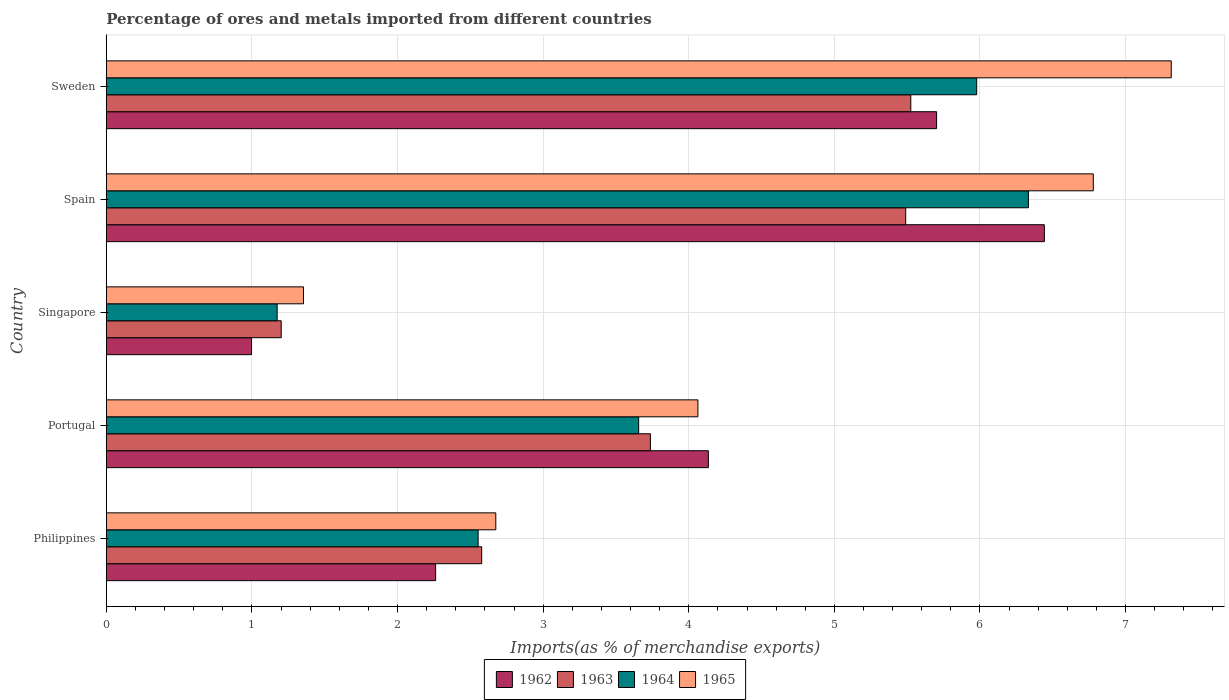Are the number of bars on each tick of the Y-axis equal?
Your answer should be very brief. Yes. How many bars are there on the 1st tick from the bottom?
Provide a short and direct response. 4. What is the label of the 2nd group of bars from the top?
Your answer should be compact. Spain. In how many cases, is the number of bars for a given country not equal to the number of legend labels?
Your response must be concise. 0. What is the percentage of imports to different countries in 1963 in Singapore?
Your answer should be compact. 1.2. Across all countries, what is the maximum percentage of imports to different countries in 1963?
Your answer should be compact. 5.52. Across all countries, what is the minimum percentage of imports to different countries in 1962?
Keep it short and to the point. 1. In which country was the percentage of imports to different countries in 1963 minimum?
Keep it short and to the point. Singapore. What is the total percentage of imports to different countries in 1965 in the graph?
Offer a terse response. 22.18. What is the difference between the percentage of imports to different countries in 1964 in Portugal and that in Singapore?
Provide a succinct answer. 2.48. What is the difference between the percentage of imports to different countries in 1962 in Sweden and the percentage of imports to different countries in 1963 in Spain?
Offer a terse response. 0.21. What is the average percentage of imports to different countries in 1963 per country?
Your answer should be very brief. 3.71. What is the difference between the percentage of imports to different countries in 1965 and percentage of imports to different countries in 1963 in Portugal?
Offer a terse response. 0.33. What is the ratio of the percentage of imports to different countries in 1964 in Portugal to that in Sweden?
Your answer should be very brief. 0.61. Is the percentage of imports to different countries in 1963 in Philippines less than that in Sweden?
Your answer should be compact. Yes. What is the difference between the highest and the second highest percentage of imports to different countries in 1963?
Offer a terse response. 0.04. What is the difference between the highest and the lowest percentage of imports to different countries in 1964?
Your answer should be compact. 5.16. Is the sum of the percentage of imports to different countries in 1965 in Singapore and Sweden greater than the maximum percentage of imports to different countries in 1962 across all countries?
Your answer should be compact. Yes. What does the 2nd bar from the top in Portugal represents?
Provide a short and direct response. 1964. What does the 3rd bar from the bottom in Sweden represents?
Offer a terse response. 1964. Is it the case that in every country, the sum of the percentage of imports to different countries in 1964 and percentage of imports to different countries in 1963 is greater than the percentage of imports to different countries in 1962?
Make the answer very short. Yes. Are all the bars in the graph horizontal?
Give a very brief answer. Yes. How many countries are there in the graph?
Ensure brevity in your answer.  5. Where does the legend appear in the graph?
Your response must be concise. Bottom center. What is the title of the graph?
Your answer should be very brief. Percentage of ores and metals imported from different countries. Does "1991" appear as one of the legend labels in the graph?
Ensure brevity in your answer.  No. What is the label or title of the X-axis?
Offer a terse response. Imports(as % of merchandise exports). What is the label or title of the Y-axis?
Your answer should be compact. Country. What is the Imports(as % of merchandise exports) of 1962 in Philippines?
Your response must be concise. 2.26. What is the Imports(as % of merchandise exports) in 1963 in Philippines?
Your answer should be very brief. 2.58. What is the Imports(as % of merchandise exports) in 1964 in Philippines?
Your response must be concise. 2.55. What is the Imports(as % of merchandise exports) of 1965 in Philippines?
Your answer should be compact. 2.67. What is the Imports(as % of merchandise exports) in 1962 in Portugal?
Keep it short and to the point. 4.13. What is the Imports(as % of merchandise exports) of 1963 in Portugal?
Provide a short and direct response. 3.74. What is the Imports(as % of merchandise exports) of 1964 in Portugal?
Your answer should be compact. 3.66. What is the Imports(as % of merchandise exports) of 1965 in Portugal?
Make the answer very short. 4.06. What is the Imports(as % of merchandise exports) in 1962 in Singapore?
Provide a short and direct response. 1. What is the Imports(as % of merchandise exports) of 1963 in Singapore?
Your response must be concise. 1.2. What is the Imports(as % of merchandise exports) of 1964 in Singapore?
Give a very brief answer. 1.17. What is the Imports(as % of merchandise exports) in 1965 in Singapore?
Give a very brief answer. 1.35. What is the Imports(as % of merchandise exports) of 1962 in Spain?
Provide a succinct answer. 6.44. What is the Imports(as % of merchandise exports) in 1963 in Spain?
Keep it short and to the point. 5.49. What is the Imports(as % of merchandise exports) in 1964 in Spain?
Keep it short and to the point. 6.33. What is the Imports(as % of merchandise exports) in 1965 in Spain?
Provide a succinct answer. 6.78. What is the Imports(as % of merchandise exports) in 1962 in Sweden?
Provide a succinct answer. 5.7. What is the Imports(as % of merchandise exports) of 1963 in Sweden?
Offer a terse response. 5.52. What is the Imports(as % of merchandise exports) in 1964 in Sweden?
Ensure brevity in your answer.  5.98. What is the Imports(as % of merchandise exports) of 1965 in Sweden?
Your answer should be compact. 7.31. Across all countries, what is the maximum Imports(as % of merchandise exports) of 1962?
Ensure brevity in your answer.  6.44. Across all countries, what is the maximum Imports(as % of merchandise exports) in 1963?
Offer a very short reply. 5.52. Across all countries, what is the maximum Imports(as % of merchandise exports) in 1964?
Provide a short and direct response. 6.33. Across all countries, what is the maximum Imports(as % of merchandise exports) in 1965?
Keep it short and to the point. 7.31. Across all countries, what is the minimum Imports(as % of merchandise exports) of 1962?
Provide a succinct answer. 1. Across all countries, what is the minimum Imports(as % of merchandise exports) of 1963?
Offer a very short reply. 1.2. Across all countries, what is the minimum Imports(as % of merchandise exports) of 1964?
Give a very brief answer. 1.17. Across all countries, what is the minimum Imports(as % of merchandise exports) in 1965?
Give a very brief answer. 1.35. What is the total Imports(as % of merchandise exports) of 1962 in the graph?
Provide a succinct answer. 19.54. What is the total Imports(as % of merchandise exports) in 1963 in the graph?
Keep it short and to the point. 18.53. What is the total Imports(as % of merchandise exports) in 1964 in the graph?
Offer a terse response. 19.69. What is the total Imports(as % of merchandise exports) in 1965 in the graph?
Offer a terse response. 22.18. What is the difference between the Imports(as % of merchandise exports) in 1962 in Philippines and that in Portugal?
Give a very brief answer. -1.87. What is the difference between the Imports(as % of merchandise exports) of 1963 in Philippines and that in Portugal?
Offer a terse response. -1.16. What is the difference between the Imports(as % of merchandise exports) of 1964 in Philippines and that in Portugal?
Keep it short and to the point. -1.1. What is the difference between the Imports(as % of merchandise exports) in 1965 in Philippines and that in Portugal?
Your answer should be very brief. -1.39. What is the difference between the Imports(as % of merchandise exports) of 1962 in Philippines and that in Singapore?
Your response must be concise. 1.26. What is the difference between the Imports(as % of merchandise exports) in 1963 in Philippines and that in Singapore?
Offer a terse response. 1.38. What is the difference between the Imports(as % of merchandise exports) in 1964 in Philippines and that in Singapore?
Provide a short and direct response. 1.38. What is the difference between the Imports(as % of merchandise exports) in 1965 in Philippines and that in Singapore?
Ensure brevity in your answer.  1.32. What is the difference between the Imports(as % of merchandise exports) in 1962 in Philippines and that in Spain?
Provide a short and direct response. -4.18. What is the difference between the Imports(as % of merchandise exports) in 1963 in Philippines and that in Spain?
Provide a succinct answer. -2.91. What is the difference between the Imports(as % of merchandise exports) of 1964 in Philippines and that in Spain?
Give a very brief answer. -3.78. What is the difference between the Imports(as % of merchandise exports) of 1965 in Philippines and that in Spain?
Ensure brevity in your answer.  -4.1. What is the difference between the Imports(as % of merchandise exports) of 1962 in Philippines and that in Sweden?
Give a very brief answer. -3.44. What is the difference between the Imports(as % of merchandise exports) of 1963 in Philippines and that in Sweden?
Your answer should be very brief. -2.95. What is the difference between the Imports(as % of merchandise exports) of 1964 in Philippines and that in Sweden?
Offer a terse response. -3.42. What is the difference between the Imports(as % of merchandise exports) of 1965 in Philippines and that in Sweden?
Provide a succinct answer. -4.64. What is the difference between the Imports(as % of merchandise exports) in 1962 in Portugal and that in Singapore?
Offer a very short reply. 3.14. What is the difference between the Imports(as % of merchandise exports) of 1963 in Portugal and that in Singapore?
Your answer should be compact. 2.54. What is the difference between the Imports(as % of merchandise exports) in 1964 in Portugal and that in Singapore?
Your answer should be compact. 2.48. What is the difference between the Imports(as % of merchandise exports) in 1965 in Portugal and that in Singapore?
Make the answer very short. 2.71. What is the difference between the Imports(as % of merchandise exports) of 1962 in Portugal and that in Spain?
Keep it short and to the point. -2.31. What is the difference between the Imports(as % of merchandise exports) of 1963 in Portugal and that in Spain?
Offer a terse response. -1.75. What is the difference between the Imports(as % of merchandise exports) of 1964 in Portugal and that in Spain?
Your answer should be very brief. -2.68. What is the difference between the Imports(as % of merchandise exports) of 1965 in Portugal and that in Spain?
Offer a terse response. -2.72. What is the difference between the Imports(as % of merchandise exports) in 1962 in Portugal and that in Sweden?
Ensure brevity in your answer.  -1.57. What is the difference between the Imports(as % of merchandise exports) of 1963 in Portugal and that in Sweden?
Provide a succinct answer. -1.79. What is the difference between the Imports(as % of merchandise exports) in 1964 in Portugal and that in Sweden?
Your answer should be compact. -2.32. What is the difference between the Imports(as % of merchandise exports) in 1965 in Portugal and that in Sweden?
Your response must be concise. -3.25. What is the difference between the Imports(as % of merchandise exports) of 1962 in Singapore and that in Spain?
Keep it short and to the point. -5.45. What is the difference between the Imports(as % of merchandise exports) of 1963 in Singapore and that in Spain?
Offer a terse response. -4.29. What is the difference between the Imports(as % of merchandise exports) of 1964 in Singapore and that in Spain?
Offer a very short reply. -5.16. What is the difference between the Imports(as % of merchandise exports) of 1965 in Singapore and that in Spain?
Offer a terse response. -5.42. What is the difference between the Imports(as % of merchandise exports) of 1962 in Singapore and that in Sweden?
Offer a terse response. -4.7. What is the difference between the Imports(as % of merchandise exports) of 1963 in Singapore and that in Sweden?
Your response must be concise. -4.32. What is the difference between the Imports(as % of merchandise exports) in 1964 in Singapore and that in Sweden?
Give a very brief answer. -4.8. What is the difference between the Imports(as % of merchandise exports) of 1965 in Singapore and that in Sweden?
Keep it short and to the point. -5.96. What is the difference between the Imports(as % of merchandise exports) of 1962 in Spain and that in Sweden?
Your response must be concise. 0.74. What is the difference between the Imports(as % of merchandise exports) in 1963 in Spain and that in Sweden?
Provide a succinct answer. -0.04. What is the difference between the Imports(as % of merchandise exports) in 1964 in Spain and that in Sweden?
Ensure brevity in your answer.  0.36. What is the difference between the Imports(as % of merchandise exports) of 1965 in Spain and that in Sweden?
Your response must be concise. -0.54. What is the difference between the Imports(as % of merchandise exports) of 1962 in Philippines and the Imports(as % of merchandise exports) of 1963 in Portugal?
Give a very brief answer. -1.47. What is the difference between the Imports(as % of merchandise exports) of 1962 in Philippines and the Imports(as % of merchandise exports) of 1964 in Portugal?
Your answer should be very brief. -1.39. What is the difference between the Imports(as % of merchandise exports) in 1962 in Philippines and the Imports(as % of merchandise exports) in 1965 in Portugal?
Provide a succinct answer. -1.8. What is the difference between the Imports(as % of merchandise exports) in 1963 in Philippines and the Imports(as % of merchandise exports) in 1964 in Portugal?
Keep it short and to the point. -1.08. What is the difference between the Imports(as % of merchandise exports) in 1963 in Philippines and the Imports(as % of merchandise exports) in 1965 in Portugal?
Keep it short and to the point. -1.48. What is the difference between the Imports(as % of merchandise exports) of 1964 in Philippines and the Imports(as % of merchandise exports) of 1965 in Portugal?
Ensure brevity in your answer.  -1.51. What is the difference between the Imports(as % of merchandise exports) of 1962 in Philippines and the Imports(as % of merchandise exports) of 1963 in Singapore?
Provide a succinct answer. 1.06. What is the difference between the Imports(as % of merchandise exports) in 1962 in Philippines and the Imports(as % of merchandise exports) in 1964 in Singapore?
Give a very brief answer. 1.09. What is the difference between the Imports(as % of merchandise exports) of 1962 in Philippines and the Imports(as % of merchandise exports) of 1965 in Singapore?
Give a very brief answer. 0.91. What is the difference between the Imports(as % of merchandise exports) in 1963 in Philippines and the Imports(as % of merchandise exports) in 1964 in Singapore?
Make the answer very short. 1.4. What is the difference between the Imports(as % of merchandise exports) of 1963 in Philippines and the Imports(as % of merchandise exports) of 1965 in Singapore?
Provide a succinct answer. 1.22. What is the difference between the Imports(as % of merchandise exports) of 1964 in Philippines and the Imports(as % of merchandise exports) of 1965 in Singapore?
Provide a succinct answer. 1.2. What is the difference between the Imports(as % of merchandise exports) of 1962 in Philippines and the Imports(as % of merchandise exports) of 1963 in Spain?
Your answer should be compact. -3.23. What is the difference between the Imports(as % of merchandise exports) in 1962 in Philippines and the Imports(as % of merchandise exports) in 1964 in Spain?
Make the answer very short. -4.07. What is the difference between the Imports(as % of merchandise exports) of 1962 in Philippines and the Imports(as % of merchandise exports) of 1965 in Spain?
Provide a succinct answer. -4.52. What is the difference between the Imports(as % of merchandise exports) of 1963 in Philippines and the Imports(as % of merchandise exports) of 1964 in Spain?
Give a very brief answer. -3.75. What is the difference between the Imports(as % of merchandise exports) of 1963 in Philippines and the Imports(as % of merchandise exports) of 1965 in Spain?
Provide a succinct answer. -4.2. What is the difference between the Imports(as % of merchandise exports) of 1964 in Philippines and the Imports(as % of merchandise exports) of 1965 in Spain?
Make the answer very short. -4.22. What is the difference between the Imports(as % of merchandise exports) of 1962 in Philippines and the Imports(as % of merchandise exports) of 1963 in Sweden?
Your response must be concise. -3.26. What is the difference between the Imports(as % of merchandise exports) in 1962 in Philippines and the Imports(as % of merchandise exports) in 1964 in Sweden?
Give a very brief answer. -3.72. What is the difference between the Imports(as % of merchandise exports) in 1962 in Philippines and the Imports(as % of merchandise exports) in 1965 in Sweden?
Offer a terse response. -5.05. What is the difference between the Imports(as % of merchandise exports) of 1963 in Philippines and the Imports(as % of merchandise exports) of 1964 in Sweden?
Your response must be concise. -3.4. What is the difference between the Imports(as % of merchandise exports) of 1963 in Philippines and the Imports(as % of merchandise exports) of 1965 in Sweden?
Your answer should be compact. -4.74. What is the difference between the Imports(as % of merchandise exports) in 1964 in Philippines and the Imports(as % of merchandise exports) in 1965 in Sweden?
Offer a terse response. -4.76. What is the difference between the Imports(as % of merchandise exports) in 1962 in Portugal and the Imports(as % of merchandise exports) in 1963 in Singapore?
Your answer should be very brief. 2.93. What is the difference between the Imports(as % of merchandise exports) in 1962 in Portugal and the Imports(as % of merchandise exports) in 1964 in Singapore?
Provide a succinct answer. 2.96. What is the difference between the Imports(as % of merchandise exports) of 1962 in Portugal and the Imports(as % of merchandise exports) of 1965 in Singapore?
Keep it short and to the point. 2.78. What is the difference between the Imports(as % of merchandise exports) in 1963 in Portugal and the Imports(as % of merchandise exports) in 1964 in Singapore?
Your response must be concise. 2.56. What is the difference between the Imports(as % of merchandise exports) of 1963 in Portugal and the Imports(as % of merchandise exports) of 1965 in Singapore?
Your answer should be very brief. 2.38. What is the difference between the Imports(as % of merchandise exports) in 1964 in Portugal and the Imports(as % of merchandise exports) in 1965 in Singapore?
Your answer should be compact. 2.3. What is the difference between the Imports(as % of merchandise exports) in 1962 in Portugal and the Imports(as % of merchandise exports) in 1963 in Spain?
Keep it short and to the point. -1.36. What is the difference between the Imports(as % of merchandise exports) in 1962 in Portugal and the Imports(as % of merchandise exports) in 1964 in Spain?
Ensure brevity in your answer.  -2.2. What is the difference between the Imports(as % of merchandise exports) of 1962 in Portugal and the Imports(as % of merchandise exports) of 1965 in Spain?
Offer a terse response. -2.64. What is the difference between the Imports(as % of merchandise exports) of 1963 in Portugal and the Imports(as % of merchandise exports) of 1964 in Spain?
Offer a terse response. -2.6. What is the difference between the Imports(as % of merchandise exports) of 1963 in Portugal and the Imports(as % of merchandise exports) of 1965 in Spain?
Provide a succinct answer. -3.04. What is the difference between the Imports(as % of merchandise exports) of 1964 in Portugal and the Imports(as % of merchandise exports) of 1965 in Spain?
Offer a very short reply. -3.12. What is the difference between the Imports(as % of merchandise exports) in 1962 in Portugal and the Imports(as % of merchandise exports) in 1963 in Sweden?
Provide a short and direct response. -1.39. What is the difference between the Imports(as % of merchandise exports) in 1962 in Portugal and the Imports(as % of merchandise exports) in 1964 in Sweden?
Make the answer very short. -1.84. What is the difference between the Imports(as % of merchandise exports) in 1962 in Portugal and the Imports(as % of merchandise exports) in 1965 in Sweden?
Ensure brevity in your answer.  -3.18. What is the difference between the Imports(as % of merchandise exports) of 1963 in Portugal and the Imports(as % of merchandise exports) of 1964 in Sweden?
Offer a very short reply. -2.24. What is the difference between the Imports(as % of merchandise exports) in 1963 in Portugal and the Imports(as % of merchandise exports) in 1965 in Sweden?
Keep it short and to the point. -3.58. What is the difference between the Imports(as % of merchandise exports) in 1964 in Portugal and the Imports(as % of merchandise exports) in 1965 in Sweden?
Provide a succinct answer. -3.66. What is the difference between the Imports(as % of merchandise exports) in 1962 in Singapore and the Imports(as % of merchandise exports) in 1963 in Spain?
Provide a succinct answer. -4.49. What is the difference between the Imports(as % of merchandise exports) of 1962 in Singapore and the Imports(as % of merchandise exports) of 1964 in Spain?
Provide a succinct answer. -5.34. What is the difference between the Imports(as % of merchandise exports) in 1962 in Singapore and the Imports(as % of merchandise exports) in 1965 in Spain?
Ensure brevity in your answer.  -5.78. What is the difference between the Imports(as % of merchandise exports) of 1963 in Singapore and the Imports(as % of merchandise exports) of 1964 in Spain?
Your answer should be very brief. -5.13. What is the difference between the Imports(as % of merchandise exports) in 1963 in Singapore and the Imports(as % of merchandise exports) in 1965 in Spain?
Keep it short and to the point. -5.58. What is the difference between the Imports(as % of merchandise exports) in 1964 in Singapore and the Imports(as % of merchandise exports) in 1965 in Spain?
Give a very brief answer. -5.61. What is the difference between the Imports(as % of merchandise exports) of 1962 in Singapore and the Imports(as % of merchandise exports) of 1963 in Sweden?
Provide a short and direct response. -4.53. What is the difference between the Imports(as % of merchandise exports) in 1962 in Singapore and the Imports(as % of merchandise exports) in 1964 in Sweden?
Provide a short and direct response. -4.98. What is the difference between the Imports(as % of merchandise exports) of 1962 in Singapore and the Imports(as % of merchandise exports) of 1965 in Sweden?
Offer a very short reply. -6.32. What is the difference between the Imports(as % of merchandise exports) in 1963 in Singapore and the Imports(as % of merchandise exports) in 1964 in Sweden?
Ensure brevity in your answer.  -4.78. What is the difference between the Imports(as % of merchandise exports) in 1963 in Singapore and the Imports(as % of merchandise exports) in 1965 in Sweden?
Your response must be concise. -6.11. What is the difference between the Imports(as % of merchandise exports) in 1964 in Singapore and the Imports(as % of merchandise exports) in 1965 in Sweden?
Provide a succinct answer. -6.14. What is the difference between the Imports(as % of merchandise exports) of 1962 in Spain and the Imports(as % of merchandise exports) of 1963 in Sweden?
Keep it short and to the point. 0.92. What is the difference between the Imports(as % of merchandise exports) in 1962 in Spain and the Imports(as % of merchandise exports) in 1964 in Sweden?
Keep it short and to the point. 0.47. What is the difference between the Imports(as % of merchandise exports) in 1962 in Spain and the Imports(as % of merchandise exports) in 1965 in Sweden?
Provide a short and direct response. -0.87. What is the difference between the Imports(as % of merchandise exports) of 1963 in Spain and the Imports(as % of merchandise exports) of 1964 in Sweden?
Give a very brief answer. -0.49. What is the difference between the Imports(as % of merchandise exports) in 1963 in Spain and the Imports(as % of merchandise exports) in 1965 in Sweden?
Provide a succinct answer. -1.82. What is the difference between the Imports(as % of merchandise exports) in 1964 in Spain and the Imports(as % of merchandise exports) in 1965 in Sweden?
Make the answer very short. -0.98. What is the average Imports(as % of merchandise exports) in 1962 per country?
Your answer should be very brief. 3.91. What is the average Imports(as % of merchandise exports) of 1963 per country?
Give a very brief answer. 3.71. What is the average Imports(as % of merchandise exports) of 1964 per country?
Your response must be concise. 3.94. What is the average Imports(as % of merchandise exports) in 1965 per country?
Make the answer very short. 4.44. What is the difference between the Imports(as % of merchandise exports) of 1962 and Imports(as % of merchandise exports) of 1963 in Philippines?
Keep it short and to the point. -0.32. What is the difference between the Imports(as % of merchandise exports) of 1962 and Imports(as % of merchandise exports) of 1964 in Philippines?
Give a very brief answer. -0.29. What is the difference between the Imports(as % of merchandise exports) in 1962 and Imports(as % of merchandise exports) in 1965 in Philippines?
Offer a very short reply. -0.41. What is the difference between the Imports(as % of merchandise exports) in 1963 and Imports(as % of merchandise exports) in 1964 in Philippines?
Make the answer very short. 0.02. What is the difference between the Imports(as % of merchandise exports) in 1963 and Imports(as % of merchandise exports) in 1965 in Philippines?
Make the answer very short. -0.1. What is the difference between the Imports(as % of merchandise exports) in 1964 and Imports(as % of merchandise exports) in 1965 in Philippines?
Provide a succinct answer. -0.12. What is the difference between the Imports(as % of merchandise exports) of 1962 and Imports(as % of merchandise exports) of 1963 in Portugal?
Your answer should be compact. 0.4. What is the difference between the Imports(as % of merchandise exports) in 1962 and Imports(as % of merchandise exports) in 1964 in Portugal?
Provide a succinct answer. 0.48. What is the difference between the Imports(as % of merchandise exports) in 1962 and Imports(as % of merchandise exports) in 1965 in Portugal?
Give a very brief answer. 0.07. What is the difference between the Imports(as % of merchandise exports) of 1963 and Imports(as % of merchandise exports) of 1964 in Portugal?
Your response must be concise. 0.08. What is the difference between the Imports(as % of merchandise exports) of 1963 and Imports(as % of merchandise exports) of 1965 in Portugal?
Your response must be concise. -0.33. What is the difference between the Imports(as % of merchandise exports) in 1964 and Imports(as % of merchandise exports) in 1965 in Portugal?
Provide a succinct answer. -0.41. What is the difference between the Imports(as % of merchandise exports) in 1962 and Imports(as % of merchandise exports) in 1963 in Singapore?
Make the answer very short. -0.2. What is the difference between the Imports(as % of merchandise exports) in 1962 and Imports(as % of merchandise exports) in 1964 in Singapore?
Make the answer very short. -0.18. What is the difference between the Imports(as % of merchandise exports) in 1962 and Imports(as % of merchandise exports) in 1965 in Singapore?
Ensure brevity in your answer.  -0.36. What is the difference between the Imports(as % of merchandise exports) of 1963 and Imports(as % of merchandise exports) of 1964 in Singapore?
Keep it short and to the point. 0.03. What is the difference between the Imports(as % of merchandise exports) of 1963 and Imports(as % of merchandise exports) of 1965 in Singapore?
Keep it short and to the point. -0.15. What is the difference between the Imports(as % of merchandise exports) of 1964 and Imports(as % of merchandise exports) of 1965 in Singapore?
Give a very brief answer. -0.18. What is the difference between the Imports(as % of merchandise exports) of 1962 and Imports(as % of merchandise exports) of 1964 in Spain?
Offer a very short reply. 0.11. What is the difference between the Imports(as % of merchandise exports) of 1962 and Imports(as % of merchandise exports) of 1965 in Spain?
Your answer should be very brief. -0.34. What is the difference between the Imports(as % of merchandise exports) of 1963 and Imports(as % of merchandise exports) of 1964 in Spain?
Your response must be concise. -0.84. What is the difference between the Imports(as % of merchandise exports) of 1963 and Imports(as % of merchandise exports) of 1965 in Spain?
Provide a short and direct response. -1.29. What is the difference between the Imports(as % of merchandise exports) of 1964 and Imports(as % of merchandise exports) of 1965 in Spain?
Offer a terse response. -0.45. What is the difference between the Imports(as % of merchandise exports) in 1962 and Imports(as % of merchandise exports) in 1963 in Sweden?
Your response must be concise. 0.18. What is the difference between the Imports(as % of merchandise exports) in 1962 and Imports(as % of merchandise exports) in 1964 in Sweden?
Provide a succinct answer. -0.28. What is the difference between the Imports(as % of merchandise exports) of 1962 and Imports(as % of merchandise exports) of 1965 in Sweden?
Provide a succinct answer. -1.61. What is the difference between the Imports(as % of merchandise exports) of 1963 and Imports(as % of merchandise exports) of 1964 in Sweden?
Provide a short and direct response. -0.45. What is the difference between the Imports(as % of merchandise exports) of 1963 and Imports(as % of merchandise exports) of 1965 in Sweden?
Keep it short and to the point. -1.79. What is the difference between the Imports(as % of merchandise exports) of 1964 and Imports(as % of merchandise exports) of 1965 in Sweden?
Keep it short and to the point. -1.34. What is the ratio of the Imports(as % of merchandise exports) in 1962 in Philippines to that in Portugal?
Your answer should be very brief. 0.55. What is the ratio of the Imports(as % of merchandise exports) in 1963 in Philippines to that in Portugal?
Provide a short and direct response. 0.69. What is the ratio of the Imports(as % of merchandise exports) in 1964 in Philippines to that in Portugal?
Keep it short and to the point. 0.7. What is the ratio of the Imports(as % of merchandise exports) in 1965 in Philippines to that in Portugal?
Make the answer very short. 0.66. What is the ratio of the Imports(as % of merchandise exports) of 1962 in Philippines to that in Singapore?
Provide a succinct answer. 2.27. What is the ratio of the Imports(as % of merchandise exports) in 1963 in Philippines to that in Singapore?
Your answer should be very brief. 2.15. What is the ratio of the Imports(as % of merchandise exports) of 1964 in Philippines to that in Singapore?
Give a very brief answer. 2.18. What is the ratio of the Imports(as % of merchandise exports) of 1965 in Philippines to that in Singapore?
Ensure brevity in your answer.  1.98. What is the ratio of the Imports(as % of merchandise exports) of 1962 in Philippines to that in Spain?
Offer a terse response. 0.35. What is the ratio of the Imports(as % of merchandise exports) in 1963 in Philippines to that in Spain?
Your answer should be very brief. 0.47. What is the ratio of the Imports(as % of merchandise exports) in 1964 in Philippines to that in Spain?
Your answer should be very brief. 0.4. What is the ratio of the Imports(as % of merchandise exports) of 1965 in Philippines to that in Spain?
Ensure brevity in your answer.  0.39. What is the ratio of the Imports(as % of merchandise exports) of 1962 in Philippines to that in Sweden?
Keep it short and to the point. 0.4. What is the ratio of the Imports(as % of merchandise exports) of 1963 in Philippines to that in Sweden?
Ensure brevity in your answer.  0.47. What is the ratio of the Imports(as % of merchandise exports) of 1964 in Philippines to that in Sweden?
Your answer should be compact. 0.43. What is the ratio of the Imports(as % of merchandise exports) in 1965 in Philippines to that in Sweden?
Give a very brief answer. 0.37. What is the ratio of the Imports(as % of merchandise exports) of 1962 in Portugal to that in Singapore?
Provide a short and direct response. 4.15. What is the ratio of the Imports(as % of merchandise exports) of 1963 in Portugal to that in Singapore?
Give a very brief answer. 3.11. What is the ratio of the Imports(as % of merchandise exports) in 1964 in Portugal to that in Singapore?
Your answer should be very brief. 3.12. What is the ratio of the Imports(as % of merchandise exports) in 1965 in Portugal to that in Singapore?
Offer a terse response. 3. What is the ratio of the Imports(as % of merchandise exports) in 1962 in Portugal to that in Spain?
Your answer should be very brief. 0.64. What is the ratio of the Imports(as % of merchandise exports) in 1963 in Portugal to that in Spain?
Offer a terse response. 0.68. What is the ratio of the Imports(as % of merchandise exports) of 1964 in Portugal to that in Spain?
Provide a short and direct response. 0.58. What is the ratio of the Imports(as % of merchandise exports) of 1965 in Portugal to that in Spain?
Your response must be concise. 0.6. What is the ratio of the Imports(as % of merchandise exports) in 1962 in Portugal to that in Sweden?
Provide a succinct answer. 0.73. What is the ratio of the Imports(as % of merchandise exports) in 1963 in Portugal to that in Sweden?
Keep it short and to the point. 0.68. What is the ratio of the Imports(as % of merchandise exports) in 1964 in Portugal to that in Sweden?
Provide a short and direct response. 0.61. What is the ratio of the Imports(as % of merchandise exports) of 1965 in Portugal to that in Sweden?
Offer a very short reply. 0.56. What is the ratio of the Imports(as % of merchandise exports) of 1962 in Singapore to that in Spain?
Give a very brief answer. 0.15. What is the ratio of the Imports(as % of merchandise exports) in 1963 in Singapore to that in Spain?
Offer a terse response. 0.22. What is the ratio of the Imports(as % of merchandise exports) of 1964 in Singapore to that in Spain?
Your response must be concise. 0.19. What is the ratio of the Imports(as % of merchandise exports) of 1965 in Singapore to that in Spain?
Offer a very short reply. 0.2. What is the ratio of the Imports(as % of merchandise exports) in 1962 in Singapore to that in Sweden?
Provide a short and direct response. 0.17. What is the ratio of the Imports(as % of merchandise exports) of 1963 in Singapore to that in Sweden?
Make the answer very short. 0.22. What is the ratio of the Imports(as % of merchandise exports) of 1964 in Singapore to that in Sweden?
Make the answer very short. 0.2. What is the ratio of the Imports(as % of merchandise exports) in 1965 in Singapore to that in Sweden?
Offer a very short reply. 0.19. What is the ratio of the Imports(as % of merchandise exports) in 1962 in Spain to that in Sweden?
Provide a succinct answer. 1.13. What is the ratio of the Imports(as % of merchandise exports) of 1963 in Spain to that in Sweden?
Your answer should be very brief. 0.99. What is the ratio of the Imports(as % of merchandise exports) of 1964 in Spain to that in Sweden?
Ensure brevity in your answer.  1.06. What is the ratio of the Imports(as % of merchandise exports) of 1965 in Spain to that in Sweden?
Your answer should be compact. 0.93. What is the difference between the highest and the second highest Imports(as % of merchandise exports) of 1962?
Keep it short and to the point. 0.74. What is the difference between the highest and the second highest Imports(as % of merchandise exports) in 1963?
Your answer should be very brief. 0.04. What is the difference between the highest and the second highest Imports(as % of merchandise exports) of 1964?
Offer a very short reply. 0.36. What is the difference between the highest and the second highest Imports(as % of merchandise exports) in 1965?
Offer a very short reply. 0.54. What is the difference between the highest and the lowest Imports(as % of merchandise exports) in 1962?
Your response must be concise. 5.45. What is the difference between the highest and the lowest Imports(as % of merchandise exports) of 1963?
Provide a succinct answer. 4.32. What is the difference between the highest and the lowest Imports(as % of merchandise exports) of 1964?
Make the answer very short. 5.16. What is the difference between the highest and the lowest Imports(as % of merchandise exports) in 1965?
Your answer should be very brief. 5.96. 